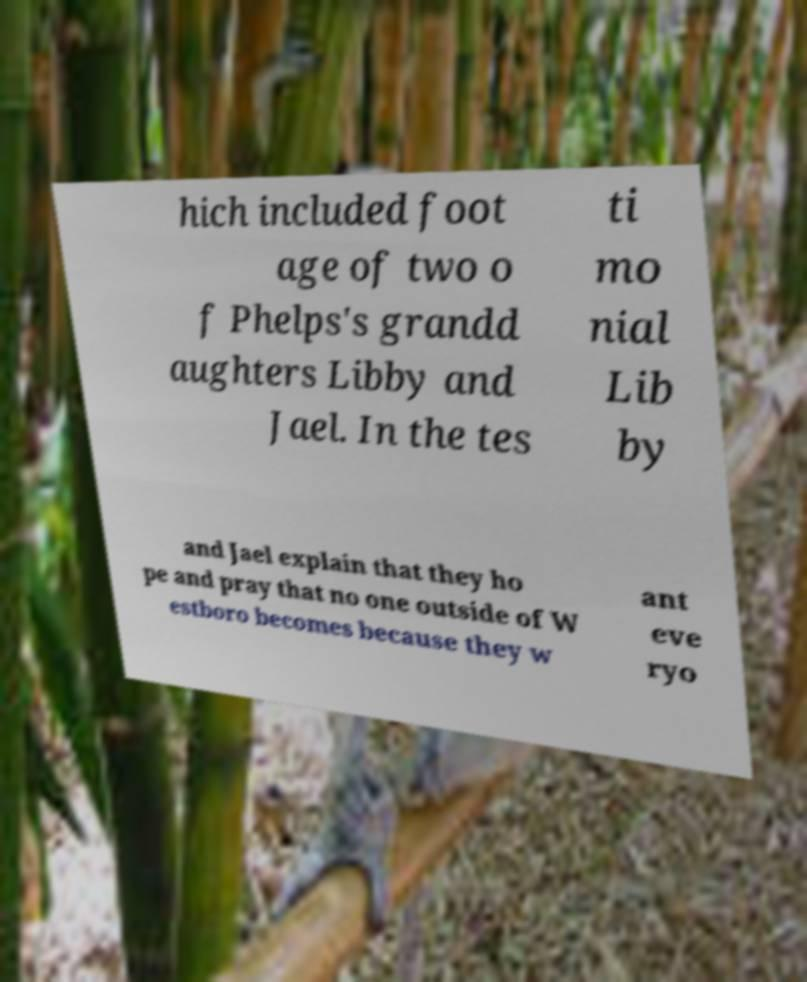There's text embedded in this image that I need extracted. Can you transcribe it verbatim? hich included foot age of two o f Phelps's grandd aughters Libby and Jael. In the tes ti mo nial Lib by and Jael explain that they ho pe and pray that no one outside of W estboro becomes because they w ant eve ryo 